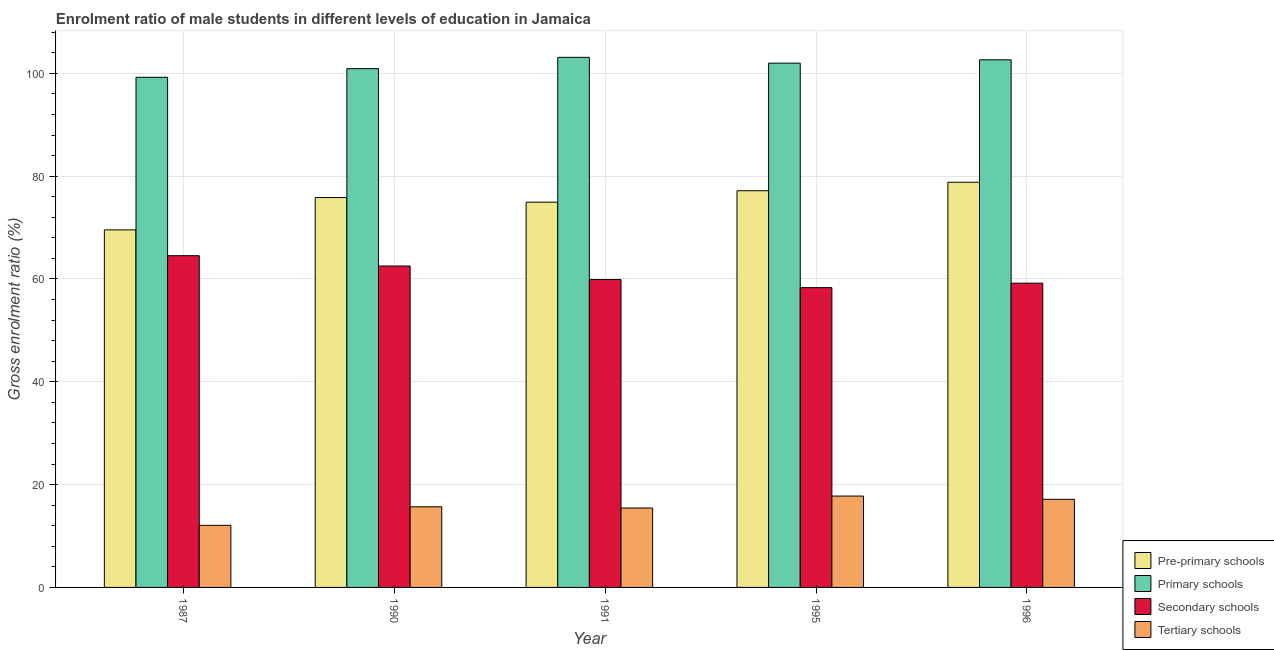How many groups of bars are there?
Ensure brevity in your answer.  5. How many bars are there on the 5th tick from the right?
Your answer should be very brief. 4. What is the label of the 1st group of bars from the left?
Offer a terse response. 1987. In how many cases, is the number of bars for a given year not equal to the number of legend labels?
Ensure brevity in your answer.  0. What is the gross enrolment ratio(female) in secondary schools in 1995?
Your answer should be very brief. 58.32. Across all years, what is the maximum gross enrolment ratio(female) in pre-primary schools?
Keep it short and to the point. 78.82. Across all years, what is the minimum gross enrolment ratio(female) in secondary schools?
Offer a very short reply. 58.32. In which year was the gross enrolment ratio(female) in tertiary schools maximum?
Provide a succinct answer. 1995. In which year was the gross enrolment ratio(female) in tertiary schools minimum?
Make the answer very short. 1987. What is the total gross enrolment ratio(female) in pre-primary schools in the graph?
Your answer should be very brief. 376.31. What is the difference between the gross enrolment ratio(female) in tertiary schools in 1990 and that in 1995?
Your response must be concise. -2.09. What is the difference between the gross enrolment ratio(female) in primary schools in 1996 and the gross enrolment ratio(female) in tertiary schools in 1987?
Offer a very short reply. 3.4. What is the average gross enrolment ratio(female) in pre-primary schools per year?
Your response must be concise. 75.26. In the year 1996, what is the difference between the gross enrolment ratio(female) in pre-primary schools and gross enrolment ratio(female) in primary schools?
Make the answer very short. 0. What is the ratio of the gross enrolment ratio(female) in pre-primary schools in 1987 to that in 1991?
Keep it short and to the point. 0.93. Is the gross enrolment ratio(female) in primary schools in 1995 less than that in 1996?
Your response must be concise. Yes. Is the difference between the gross enrolment ratio(female) in tertiary schools in 1987 and 1996 greater than the difference between the gross enrolment ratio(female) in primary schools in 1987 and 1996?
Make the answer very short. No. What is the difference between the highest and the second highest gross enrolment ratio(female) in primary schools?
Your answer should be very brief. 0.48. What is the difference between the highest and the lowest gross enrolment ratio(female) in secondary schools?
Give a very brief answer. 6.21. Is it the case that in every year, the sum of the gross enrolment ratio(female) in primary schools and gross enrolment ratio(female) in secondary schools is greater than the sum of gross enrolment ratio(female) in tertiary schools and gross enrolment ratio(female) in pre-primary schools?
Your answer should be very brief. Yes. What does the 3rd bar from the left in 1991 represents?
Give a very brief answer. Secondary schools. What does the 1st bar from the right in 1995 represents?
Your answer should be compact. Tertiary schools. Is it the case that in every year, the sum of the gross enrolment ratio(female) in pre-primary schools and gross enrolment ratio(female) in primary schools is greater than the gross enrolment ratio(female) in secondary schools?
Make the answer very short. Yes. How many bars are there?
Make the answer very short. 20. Are all the bars in the graph horizontal?
Offer a very short reply. No. Does the graph contain grids?
Your answer should be compact. Yes. How many legend labels are there?
Keep it short and to the point. 4. How are the legend labels stacked?
Offer a very short reply. Vertical. What is the title of the graph?
Your answer should be very brief. Enrolment ratio of male students in different levels of education in Jamaica. What is the Gross enrolment ratio (%) of Pre-primary schools in 1987?
Your response must be concise. 69.55. What is the Gross enrolment ratio (%) of Primary schools in 1987?
Provide a succinct answer. 99.23. What is the Gross enrolment ratio (%) of Secondary schools in 1987?
Your answer should be very brief. 64.53. What is the Gross enrolment ratio (%) of Tertiary schools in 1987?
Give a very brief answer. 12.08. What is the Gross enrolment ratio (%) in Pre-primary schools in 1990?
Offer a terse response. 75.84. What is the Gross enrolment ratio (%) of Primary schools in 1990?
Your answer should be very brief. 100.91. What is the Gross enrolment ratio (%) in Secondary schools in 1990?
Offer a terse response. 62.52. What is the Gross enrolment ratio (%) of Tertiary schools in 1990?
Keep it short and to the point. 15.69. What is the Gross enrolment ratio (%) in Pre-primary schools in 1991?
Make the answer very short. 74.94. What is the Gross enrolment ratio (%) in Primary schools in 1991?
Your response must be concise. 103.12. What is the Gross enrolment ratio (%) in Secondary schools in 1991?
Offer a terse response. 59.9. What is the Gross enrolment ratio (%) of Tertiary schools in 1991?
Offer a terse response. 15.45. What is the Gross enrolment ratio (%) of Pre-primary schools in 1995?
Offer a very short reply. 77.16. What is the Gross enrolment ratio (%) of Primary schools in 1995?
Offer a terse response. 101.99. What is the Gross enrolment ratio (%) in Secondary schools in 1995?
Keep it short and to the point. 58.32. What is the Gross enrolment ratio (%) of Tertiary schools in 1995?
Provide a succinct answer. 17.78. What is the Gross enrolment ratio (%) of Pre-primary schools in 1996?
Your answer should be very brief. 78.82. What is the Gross enrolment ratio (%) of Primary schools in 1996?
Provide a short and direct response. 102.64. What is the Gross enrolment ratio (%) of Secondary schools in 1996?
Keep it short and to the point. 59.18. What is the Gross enrolment ratio (%) of Tertiary schools in 1996?
Your answer should be compact. 17.14. Across all years, what is the maximum Gross enrolment ratio (%) of Pre-primary schools?
Your answer should be very brief. 78.82. Across all years, what is the maximum Gross enrolment ratio (%) in Primary schools?
Keep it short and to the point. 103.12. Across all years, what is the maximum Gross enrolment ratio (%) in Secondary schools?
Offer a very short reply. 64.53. Across all years, what is the maximum Gross enrolment ratio (%) of Tertiary schools?
Your answer should be very brief. 17.78. Across all years, what is the minimum Gross enrolment ratio (%) of Pre-primary schools?
Make the answer very short. 69.55. Across all years, what is the minimum Gross enrolment ratio (%) in Primary schools?
Make the answer very short. 99.23. Across all years, what is the minimum Gross enrolment ratio (%) of Secondary schools?
Your answer should be very brief. 58.32. Across all years, what is the minimum Gross enrolment ratio (%) in Tertiary schools?
Give a very brief answer. 12.08. What is the total Gross enrolment ratio (%) in Pre-primary schools in the graph?
Your answer should be compact. 376.31. What is the total Gross enrolment ratio (%) of Primary schools in the graph?
Make the answer very short. 507.88. What is the total Gross enrolment ratio (%) in Secondary schools in the graph?
Offer a terse response. 304.45. What is the total Gross enrolment ratio (%) in Tertiary schools in the graph?
Offer a terse response. 78.13. What is the difference between the Gross enrolment ratio (%) in Pre-primary schools in 1987 and that in 1990?
Ensure brevity in your answer.  -6.28. What is the difference between the Gross enrolment ratio (%) of Primary schools in 1987 and that in 1990?
Provide a short and direct response. -1.68. What is the difference between the Gross enrolment ratio (%) of Secondary schools in 1987 and that in 1990?
Offer a terse response. 2.01. What is the difference between the Gross enrolment ratio (%) in Tertiary schools in 1987 and that in 1990?
Keep it short and to the point. -3.61. What is the difference between the Gross enrolment ratio (%) in Pre-primary schools in 1987 and that in 1991?
Ensure brevity in your answer.  -5.39. What is the difference between the Gross enrolment ratio (%) of Primary schools in 1987 and that in 1991?
Your answer should be compact. -3.88. What is the difference between the Gross enrolment ratio (%) in Secondary schools in 1987 and that in 1991?
Your response must be concise. 4.63. What is the difference between the Gross enrolment ratio (%) of Tertiary schools in 1987 and that in 1991?
Provide a succinct answer. -3.36. What is the difference between the Gross enrolment ratio (%) of Pre-primary schools in 1987 and that in 1995?
Your response must be concise. -7.61. What is the difference between the Gross enrolment ratio (%) in Primary schools in 1987 and that in 1995?
Your answer should be compact. -2.75. What is the difference between the Gross enrolment ratio (%) of Secondary schools in 1987 and that in 1995?
Provide a short and direct response. 6.21. What is the difference between the Gross enrolment ratio (%) in Tertiary schools in 1987 and that in 1995?
Your response must be concise. -5.69. What is the difference between the Gross enrolment ratio (%) of Pre-primary schools in 1987 and that in 1996?
Give a very brief answer. -9.26. What is the difference between the Gross enrolment ratio (%) in Primary schools in 1987 and that in 1996?
Provide a short and direct response. -3.4. What is the difference between the Gross enrolment ratio (%) in Secondary schools in 1987 and that in 1996?
Provide a succinct answer. 5.35. What is the difference between the Gross enrolment ratio (%) of Tertiary schools in 1987 and that in 1996?
Provide a short and direct response. -5.06. What is the difference between the Gross enrolment ratio (%) of Pre-primary schools in 1990 and that in 1991?
Offer a terse response. 0.9. What is the difference between the Gross enrolment ratio (%) of Primary schools in 1990 and that in 1991?
Make the answer very short. -2.2. What is the difference between the Gross enrolment ratio (%) in Secondary schools in 1990 and that in 1991?
Provide a succinct answer. 2.62. What is the difference between the Gross enrolment ratio (%) of Tertiary schools in 1990 and that in 1991?
Provide a succinct answer. 0.24. What is the difference between the Gross enrolment ratio (%) in Pre-primary schools in 1990 and that in 1995?
Offer a terse response. -1.32. What is the difference between the Gross enrolment ratio (%) of Primary schools in 1990 and that in 1995?
Provide a short and direct response. -1.08. What is the difference between the Gross enrolment ratio (%) of Secondary schools in 1990 and that in 1995?
Provide a short and direct response. 4.2. What is the difference between the Gross enrolment ratio (%) in Tertiary schools in 1990 and that in 1995?
Make the answer very short. -2.09. What is the difference between the Gross enrolment ratio (%) of Pre-primary schools in 1990 and that in 1996?
Provide a succinct answer. -2.98. What is the difference between the Gross enrolment ratio (%) of Primary schools in 1990 and that in 1996?
Keep it short and to the point. -1.72. What is the difference between the Gross enrolment ratio (%) in Secondary schools in 1990 and that in 1996?
Make the answer very short. 3.34. What is the difference between the Gross enrolment ratio (%) of Tertiary schools in 1990 and that in 1996?
Offer a terse response. -1.45. What is the difference between the Gross enrolment ratio (%) in Pre-primary schools in 1991 and that in 1995?
Offer a very short reply. -2.22. What is the difference between the Gross enrolment ratio (%) of Primary schools in 1991 and that in 1995?
Offer a very short reply. 1.13. What is the difference between the Gross enrolment ratio (%) in Secondary schools in 1991 and that in 1995?
Offer a very short reply. 1.58. What is the difference between the Gross enrolment ratio (%) in Tertiary schools in 1991 and that in 1995?
Provide a succinct answer. -2.33. What is the difference between the Gross enrolment ratio (%) in Pre-primary schools in 1991 and that in 1996?
Give a very brief answer. -3.88. What is the difference between the Gross enrolment ratio (%) of Primary schools in 1991 and that in 1996?
Ensure brevity in your answer.  0.48. What is the difference between the Gross enrolment ratio (%) of Secondary schools in 1991 and that in 1996?
Give a very brief answer. 0.71. What is the difference between the Gross enrolment ratio (%) of Tertiary schools in 1991 and that in 1996?
Your answer should be very brief. -1.7. What is the difference between the Gross enrolment ratio (%) in Pre-primary schools in 1995 and that in 1996?
Make the answer very short. -1.65. What is the difference between the Gross enrolment ratio (%) of Primary schools in 1995 and that in 1996?
Offer a terse response. -0.65. What is the difference between the Gross enrolment ratio (%) of Secondary schools in 1995 and that in 1996?
Your response must be concise. -0.87. What is the difference between the Gross enrolment ratio (%) in Tertiary schools in 1995 and that in 1996?
Offer a very short reply. 0.63. What is the difference between the Gross enrolment ratio (%) in Pre-primary schools in 1987 and the Gross enrolment ratio (%) in Primary schools in 1990?
Your answer should be compact. -31.36. What is the difference between the Gross enrolment ratio (%) in Pre-primary schools in 1987 and the Gross enrolment ratio (%) in Secondary schools in 1990?
Your answer should be very brief. 7.03. What is the difference between the Gross enrolment ratio (%) of Pre-primary schools in 1987 and the Gross enrolment ratio (%) of Tertiary schools in 1990?
Your answer should be very brief. 53.87. What is the difference between the Gross enrolment ratio (%) of Primary schools in 1987 and the Gross enrolment ratio (%) of Secondary schools in 1990?
Keep it short and to the point. 36.71. What is the difference between the Gross enrolment ratio (%) of Primary schools in 1987 and the Gross enrolment ratio (%) of Tertiary schools in 1990?
Keep it short and to the point. 83.54. What is the difference between the Gross enrolment ratio (%) in Secondary schools in 1987 and the Gross enrolment ratio (%) in Tertiary schools in 1990?
Your answer should be very brief. 48.84. What is the difference between the Gross enrolment ratio (%) of Pre-primary schools in 1987 and the Gross enrolment ratio (%) of Primary schools in 1991?
Your answer should be compact. -33.56. What is the difference between the Gross enrolment ratio (%) of Pre-primary schools in 1987 and the Gross enrolment ratio (%) of Secondary schools in 1991?
Your answer should be very brief. 9.66. What is the difference between the Gross enrolment ratio (%) in Pre-primary schools in 1987 and the Gross enrolment ratio (%) in Tertiary schools in 1991?
Provide a short and direct response. 54.11. What is the difference between the Gross enrolment ratio (%) in Primary schools in 1987 and the Gross enrolment ratio (%) in Secondary schools in 1991?
Your answer should be compact. 39.34. What is the difference between the Gross enrolment ratio (%) of Primary schools in 1987 and the Gross enrolment ratio (%) of Tertiary schools in 1991?
Make the answer very short. 83.79. What is the difference between the Gross enrolment ratio (%) of Secondary schools in 1987 and the Gross enrolment ratio (%) of Tertiary schools in 1991?
Make the answer very short. 49.08. What is the difference between the Gross enrolment ratio (%) of Pre-primary schools in 1987 and the Gross enrolment ratio (%) of Primary schools in 1995?
Give a very brief answer. -32.43. What is the difference between the Gross enrolment ratio (%) in Pre-primary schools in 1987 and the Gross enrolment ratio (%) in Secondary schools in 1995?
Make the answer very short. 11.24. What is the difference between the Gross enrolment ratio (%) of Pre-primary schools in 1987 and the Gross enrolment ratio (%) of Tertiary schools in 1995?
Provide a succinct answer. 51.78. What is the difference between the Gross enrolment ratio (%) in Primary schools in 1987 and the Gross enrolment ratio (%) in Secondary schools in 1995?
Offer a terse response. 40.92. What is the difference between the Gross enrolment ratio (%) in Primary schools in 1987 and the Gross enrolment ratio (%) in Tertiary schools in 1995?
Offer a very short reply. 81.46. What is the difference between the Gross enrolment ratio (%) of Secondary schools in 1987 and the Gross enrolment ratio (%) of Tertiary schools in 1995?
Offer a terse response. 46.76. What is the difference between the Gross enrolment ratio (%) in Pre-primary schools in 1987 and the Gross enrolment ratio (%) in Primary schools in 1996?
Make the answer very short. -33.08. What is the difference between the Gross enrolment ratio (%) in Pre-primary schools in 1987 and the Gross enrolment ratio (%) in Secondary schools in 1996?
Your answer should be compact. 10.37. What is the difference between the Gross enrolment ratio (%) in Pre-primary schools in 1987 and the Gross enrolment ratio (%) in Tertiary schools in 1996?
Offer a very short reply. 52.41. What is the difference between the Gross enrolment ratio (%) in Primary schools in 1987 and the Gross enrolment ratio (%) in Secondary schools in 1996?
Ensure brevity in your answer.  40.05. What is the difference between the Gross enrolment ratio (%) in Primary schools in 1987 and the Gross enrolment ratio (%) in Tertiary schools in 1996?
Your answer should be very brief. 82.09. What is the difference between the Gross enrolment ratio (%) of Secondary schools in 1987 and the Gross enrolment ratio (%) of Tertiary schools in 1996?
Ensure brevity in your answer.  47.39. What is the difference between the Gross enrolment ratio (%) in Pre-primary schools in 1990 and the Gross enrolment ratio (%) in Primary schools in 1991?
Ensure brevity in your answer.  -27.28. What is the difference between the Gross enrolment ratio (%) in Pre-primary schools in 1990 and the Gross enrolment ratio (%) in Secondary schools in 1991?
Offer a terse response. 15.94. What is the difference between the Gross enrolment ratio (%) in Pre-primary schools in 1990 and the Gross enrolment ratio (%) in Tertiary schools in 1991?
Give a very brief answer. 60.39. What is the difference between the Gross enrolment ratio (%) in Primary schools in 1990 and the Gross enrolment ratio (%) in Secondary schools in 1991?
Your response must be concise. 41.01. What is the difference between the Gross enrolment ratio (%) of Primary schools in 1990 and the Gross enrolment ratio (%) of Tertiary schools in 1991?
Give a very brief answer. 85.47. What is the difference between the Gross enrolment ratio (%) in Secondary schools in 1990 and the Gross enrolment ratio (%) in Tertiary schools in 1991?
Your response must be concise. 47.07. What is the difference between the Gross enrolment ratio (%) of Pre-primary schools in 1990 and the Gross enrolment ratio (%) of Primary schools in 1995?
Provide a short and direct response. -26.15. What is the difference between the Gross enrolment ratio (%) in Pre-primary schools in 1990 and the Gross enrolment ratio (%) in Secondary schools in 1995?
Ensure brevity in your answer.  17.52. What is the difference between the Gross enrolment ratio (%) in Pre-primary schools in 1990 and the Gross enrolment ratio (%) in Tertiary schools in 1995?
Give a very brief answer. 58.06. What is the difference between the Gross enrolment ratio (%) of Primary schools in 1990 and the Gross enrolment ratio (%) of Secondary schools in 1995?
Give a very brief answer. 42.59. What is the difference between the Gross enrolment ratio (%) of Primary schools in 1990 and the Gross enrolment ratio (%) of Tertiary schools in 1995?
Offer a very short reply. 83.14. What is the difference between the Gross enrolment ratio (%) in Secondary schools in 1990 and the Gross enrolment ratio (%) in Tertiary schools in 1995?
Your answer should be very brief. 44.74. What is the difference between the Gross enrolment ratio (%) of Pre-primary schools in 1990 and the Gross enrolment ratio (%) of Primary schools in 1996?
Offer a very short reply. -26.8. What is the difference between the Gross enrolment ratio (%) in Pre-primary schools in 1990 and the Gross enrolment ratio (%) in Secondary schools in 1996?
Your answer should be compact. 16.66. What is the difference between the Gross enrolment ratio (%) in Pre-primary schools in 1990 and the Gross enrolment ratio (%) in Tertiary schools in 1996?
Keep it short and to the point. 58.7. What is the difference between the Gross enrolment ratio (%) of Primary schools in 1990 and the Gross enrolment ratio (%) of Secondary schools in 1996?
Provide a succinct answer. 41.73. What is the difference between the Gross enrolment ratio (%) in Primary schools in 1990 and the Gross enrolment ratio (%) in Tertiary schools in 1996?
Your response must be concise. 83.77. What is the difference between the Gross enrolment ratio (%) of Secondary schools in 1990 and the Gross enrolment ratio (%) of Tertiary schools in 1996?
Keep it short and to the point. 45.38. What is the difference between the Gross enrolment ratio (%) in Pre-primary schools in 1991 and the Gross enrolment ratio (%) in Primary schools in 1995?
Give a very brief answer. -27.05. What is the difference between the Gross enrolment ratio (%) of Pre-primary schools in 1991 and the Gross enrolment ratio (%) of Secondary schools in 1995?
Give a very brief answer. 16.62. What is the difference between the Gross enrolment ratio (%) in Pre-primary schools in 1991 and the Gross enrolment ratio (%) in Tertiary schools in 1995?
Your response must be concise. 57.16. What is the difference between the Gross enrolment ratio (%) in Primary schools in 1991 and the Gross enrolment ratio (%) in Secondary schools in 1995?
Offer a very short reply. 44.8. What is the difference between the Gross enrolment ratio (%) in Primary schools in 1991 and the Gross enrolment ratio (%) in Tertiary schools in 1995?
Your answer should be compact. 85.34. What is the difference between the Gross enrolment ratio (%) in Secondary schools in 1991 and the Gross enrolment ratio (%) in Tertiary schools in 1995?
Provide a succinct answer. 42.12. What is the difference between the Gross enrolment ratio (%) of Pre-primary schools in 1991 and the Gross enrolment ratio (%) of Primary schools in 1996?
Make the answer very short. -27.7. What is the difference between the Gross enrolment ratio (%) of Pre-primary schools in 1991 and the Gross enrolment ratio (%) of Secondary schools in 1996?
Keep it short and to the point. 15.76. What is the difference between the Gross enrolment ratio (%) in Pre-primary schools in 1991 and the Gross enrolment ratio (%) in Tertiary schools in 1996?
Your answer should be very brief. 57.8. What is the difference between the Gross enrolment ratio (%) in Primary schools in 1991 and the Gross enrolment ratio (%) in Secondary schools in 1996?
Offer a very short reply. 43.93. What is the difference between the Gross enrolment ratio (%) of Primary schools in 1991 and the Gross enrolment ratio (%) of Tertiary schools in 1996?
Keep it short and to the point. 85.98. What is the difference between the Gross enrolment ratio (%) in Secondary schools in 1991 and the Gross enrolment ratio (%) in Tertiary schools in 1996?
Provide a succinct answer. 42.76. What is the difference between the Gross enrolment ratio (%) in Pre-primary schools in 1995 and the Gross enrolment ratio (%) in Primary schools in 1996?
Ensure brevity in your answer.  -25.47. What is the difference between the Gross enrolment ratio (%) in Pre-primary schools in 1995 and the Gross enrolment ratio (%) in Secondary schools in 1996?
Provide a short and direct response. 17.98. What is the difference between the Gross enrolment ratio (%) of Pre-primary schools in 1995 and the Gross enrolment ratio (%) of Tertiary schools in 1996?
Your answer should be compact. 60.02. What is the difference between the Gross enrolment ratio (%) of Primary schools in 1995 and the Gross enrolment ratio (%) of Secondary schools in 1996?
Provide a succinct answer. 42.8. What is the difference between the Gross enrolment ratio (%) of Primary schools in 1995 and the Gross enrolment ratio (%) of Tertiary schools in 1996?
Give a very brief answer. 84.85. What is the difference between the Gross enrolment ratio (%) of Secondary schools in 1995 and the Gross enrolment ratio (%) of Tertiary schools in 1996?
Offer a very short reply. 41.18. What is the average Gross enrolment ratio (%) of Pre-primary schools per year?
Offer a very short reply. 75.26. What is the average Gross enrolment ratio (%) of Primary schools per year?
Your answer should be compact. 101.58. What is the average Gross enrolment ratio (%) in Secondary schools per year?
Make the answer very short. 60.89. What is the average Gross enrolment ratio (%) of Tertiary schools per year?
Keep it short and to the point. 15.63. In the year 1987, what is the difference between the Gross enrolment ratio (%) of Pre-primary schools and Gross enrolment ratio (%) of Primary schools?
Your response must be concise. -29.68. In the year 1987, what is the difference between the Gross enrolment ratio (%) of Pre-primary schools and Gross enrolment ratio (%) of Secondary schools?
Your answer should be very brief. 5.02. In the year 1987, what is the difference between the Gross enrolment ratio (%) in Pre-primary schools and Gross enrolment ratio (%) in Tertiary schools?
Your answer should be compact. 57.47. In the year 1987, what is the difference between the Gross enrolment ratio (%) in Primary schools and Gross enrolment ratio (%) in Secondary schools?
Give a very brief answer. 34.7. In the year 1987, what is the difference between the Gross enrolment ratio (%) of Primary schools and Gross enrolment ratio (%) of Tertiary schools?
Keep it short and to the point. 87.15. In the year 1987, what is the difference between the Gross enrolment ratio (%) in Secondary schools and Gross enrolment ratio (%) in Tertiary schools?
Make the answer very short. 52.45. In the year 1990, what is the difference between the Gross enrolment ratio (%) of Pre-primary schools and Gross enrolment ratio (%) of Primary schools?
Provide a succinct answer. -25.07. In the year 1990, what is the difference between the Gross enrolment ratio (%) of Pre-primary schools and Gross enrolment ratio (%) of Secondary schools?
Provide a short and direct response. 13.32. In the year 1990, what is the difference between the Gross enrolment ratio (%) in Pre-primary schools and Gross enrolment ratio (%) in Tertiary schools?
Give a very brief answer. 60.15. In the year 1990, what is the difference between the Gross enrolment ratio (%) in Primary schools and Gross enrolment ratio (%) in Secondary schools?
Offer a very short reply. 38.39. In the year 1990, what is the difference between the Gross enrolment ratio (%) of Primary schools and Gross enrolment ratio (%) of Tertiary schools?
Keep it short and to the point. 85.22. In the year 1990, what is the difference between the Gross enrolment ratio (%) in Secondary schools and Gross enrolment ratio (%) in Tertiary schools?
Your answer should be compact. 46.83. In the year 1991, what is the difference between the Gross enrolment ratio (%) in Pre-primary schools and Gross enrolment ratio (%) in Primary schools?
Your response must be concise. -28.18. In the year 1991, what is the difference between the Gross enrolment ratio (%) of Pre-primary schools and Gross enrolment ratio (%) of Secondary schools?
Give a very brief answer. 15.04. In the year 1991, what is the difference between the Gross enrolment ratio (%) in Pre-primary schools and Gross enrolment ratio (%) in Tertiary schools?
Your response must be concise. 59.49. In the year 1991, what is the difference between the Gross enrolment ratio (%) in Primary schools and Gross enrolment ratio (%) in Secondary schools?
Ensure brevity in your answer.  43.22. In the year 1991, what is the difference between the Gross enrolment ratio (%) in Primary schools and Gross enrolment ratio (%) in Tertiary schools?
Keep it short and to the point. 87.67. In the year 1991, what is the difference between the Gross enrolment ratio (%) of Secondary schools and Gross enrolment ratio (%) of Tertiary schools?
Keep it short and to the point. 44.45. In the year 1995, what is the difference between the Gross enrolment ratio (%) in Pre-primary schools and Gross enrolment ratio (%) in Primary schools?
Ensure brevity in your answer.  -24.82. In the year 1995, what is the difference between the Gross enrolment ratio (%) in Pre-primary schools and Gross enrolment ratio (%) in Secondary schools?
Offer a terse response. 18.85. In the year 1995, what is the difference between the Gross enrolment ratio (%) of Pre-primary schools and Gross enrolment ratio (%) of Tertiary schools?
Provide a short and direct response. 59.39. In the year 1995, what is the difference between the Gross enrolment ratio (%) in Primary schools and Gross enrolment ratio (%) in Secondary schools?
Your answer should be compact. 43.67. In the year 1995, what is the difference between the Gross enrolment ratio (%) in Primary schools and Gross enrolment ratio (%) in Tertiary schools?
Your answer should be compact. 84.21. In the year 1995, what is the difference between the Gross enrolment ratio (%) of Secondary schools and Gross enrolment ratio (%) of Tertiary schools?
Your answer should be very brief. 40.54. In the year 1996, what is the difference between the Gross enrolment ratio (%) of Pre-primary schools and Gross enrolment ratio (%) of Primary schools?
Ensure brevity in your answer.  -23.82. In the year 1996, what is the difference between the Gross enrolment ratio (%) in Pre-primary schools and Gross enrolment ratio (%) in Secondary schools?
Provide a short and direct response. 19.63. In the year 1996, what is the difference between the Gross enrolment ratio (%) of Pre-primary schools and Gross enrolment ratio (%) of Tertiary schools?
Ensure brevity in your answer.  61.68. In the year 1996, what is the difference between the Gross enrolment ratio (%) of Primary schools and Gross enrolment ratio (%) of Secondary schools?
Your answer should be compact. 43.45. In the year 1996, what is the difference between the Gross enrolment ratio (%) in Primary schools and Gross enrolment ratio (%) in Tertiary schools?
Ensure brevity in your answer.  85.49. In the year 1996, what is the difference between the Gross enrolment ratio (%) of Secondary schools and Gross enrolment ratio (%) of Tertiary schools?
Offer a terse response. 42.04. What is the ratio of the Gross enrolment ratio (%) in Pre-primary schools in 1987 to that in 1990?
Your response must be concise. 0.92. What is the ratio of the Gross enrolment ratio (%) in Primary schools in 1987 to that in 1990?
Your response must be concise. 0.98. What is the ratio of the Gross enrolment ratio (%) of Secondary schools in 1987 to that in 1990?
Your answer should be very brief. 1.03. What is the ratio of the Gross enrolment ratio (%) in Tertiary schools in 1987 to that in 1990?
Your answer should be very brief. 0.77. What is the ratio of the Gross enrolment ratio (%) in Pre-primary schools in 1987 to that in 1991?
Ensure brevity in your answer.  0.93. What is the ratio of the Gross enrolment ratio (%) of Primary schools in 1987 to that in 1991?
Keep it short and to the point. 0.96. What is the ratio of the Gross enrolment ratio (%) of Secondary schools in 1987 to that in 1991?
Your answer should be very brief. 1.08. What is the ratio of the Gross enrolment ratio (%) of Tertiary schools in 1987 to that in 1991?
Ensure brevity in your answer.  0.78. What is the ratio of the Gross enrolment ratio (%) in Pre-primary schools in 1987 to that in 1995?
Provide a short and direct response. 0.9. What is the ratio of the Gross enrolment ratio (%) of Primary schools in 1987 to that in 1995?
Offer a terse response. 0.97. What is the ratio of the Gross enrolment ratio (%) of Secondary schools in 1987 to that in 1995?
Provide a short and direct response. 1.11. What is the ratio of the Gross enrolment ratio (%) in Tertiary schools in 1987 to that in 1995?
Keep it short and to the point. 0.68. What is the ratio of the Gross enrolment ratio (%) in Pre-primary schools in 1987 to that in 1996?
Keep it short and to the point. 0.88. What is the ratio of the Gross enrolment ratio (%) in Primary schools in 1987 to that in 1996?
Your answer should be compact. 0.97. What is the ratio of the Gross enrolment ratio (%) in Secondary schools in 1987 to that in 1996?
Offer a terse response. 1.09. What is the ratio of the Gross enrolment ratio (%) in Tertiary schools in 1987 to that in 1996?
Provide a short and direct response. 0.7. What is the ratio of the Gross enrolment ratio (%) in Pre-primary schools in 1990 to that in 1991?
Ensure brevity in your answer.  1.01. What is the ratio of the Gross enrolment ratio (%) of Primary schools in 1990 to that in 1991?
Your answer should be compact. 0.98. What is the ratio of the Gross enrolment ratio (%) in Secondary schools in 1990 to that in 1991?
Offer a very short reply. 1.04. What is the ratio of the Gross enrolment ratio (%) of Tertiary schools in 1990 to that in 1991?
Ensure brevity in your answer.  1.02. What is the ratio of the Gross enrolment ratio (%) in Pre-primary schools in 1990 to that in 1995?
Ensure brevity in your answer.  0.98. What is the ratio of the Gross enrolment ratio (%) of Secondary schools in 1990 to that in 1995?
Provide a succinct answer. 1.07. What is the ratio of the Gross enrolment ratio (%) in Tertiary schools in 1990 to that in 1995?
Keep it short and to the point. 0.88. What is the ratio of the Gross enrolment ratio (%) in Pre-primary schools in 1990 to that in 1996?
Provide a succinct answer. 0.96. What is the ratio of the Gross enrolment ratio (%) of Primary schools in 1990 to that in 1996?
Make the answer very short. 0.98. What is the ratio of the Gross enrolment ratio (%) in Secondary schools in 1990 to that in 1996?
Your answer should be compact. 1.06. What is the ratio of the Gross enrolment ratio (%) in Tertiary schools in 1990 to that in 1996?
Offer a terse response. 0.92. What is the ratio of the Gross enrolment ratio (%) of Pre-primary schools in 1991 to that in 1995?
Offer a very short reply. 0.97. What is the ratio of the Gross enrolment ratio (%) in Primary schools in 1991 to that in 1995?
Ensure brevity in your answer.  1.01. What is the ratio of the Gross enrolment ratio (%) of Secondary schools in 1991 to that in 1995?
Make the answer very short. 1.03. What is the ratio of the Gross enrolment ratio (%) of Tertiary schools in 1991 to that in 1995?
Offer a very short reply. 0.87. What is the ratio of the Gross enrolment ratio (%) of Pre-primary schools in 1991 to that in 1996?
Keep it short and to the point. 0.95. What is the ratio of the Gross enrolment ratio (%) in Primary schools in 1991 to that in 1996?
Provide a short and direct response. 1. What is the ratio of the Gross enrolment ratio (%) in Secondary schools in 1991 to that in 1996?
Your response must be concise. 1.01. What is the ratio of the Gross enrolment ratio (%) of Tertiary schools in 1991 to that in 1996?
Your answer should be very brief. 0.9. What is the ratio of the Gross enrolment ratio (%) in Primary schools in 1995 to that in 1996?
Provide a short and direct response. 0.99. What is the ratio of the Gross enrolment ratio (%) in Secondary schools in 1995 to that in 1996?
Offer a terse response. 0.99. What is the difference between the highest and the second highest Gross enrolment ratio (%) in Pre-primary schools?
Your answer should be compact. 1.65. What is the difference between the highest and the second highest Gross enrolment ratio (%) in Primary schools?
Ensure brevity in your answer.  0.48. What is the difference between the highest and the second highest Gross enrolment ratio (%) of Secondary schools?
Ensure brevity in your answer.  2.01. What is the difference between the highest and the second highest Gross enrolment ratio (%) of Tertiary schools?
Ensure brevity in your answer.  0.63. What is the difference between the highest and the lowest Gross enrolment ratio (%) in Pre-primary schools?
Provide a succinct answer. 9.26. What is the difference between the highest and the lowest Gross enrolment ratio (%) of Primary schools?
Provide a succinct answer. 3.88. What is the difference between the highest and the lowest Gross enrolment ratio (%) of Secondary schools?
Provide a short and direct response. 6.21. What is the difference between the highest and the lowest Gross enrolment ratio (%) of Tertiary schools?
Provide a succinct answer. 5.69. 